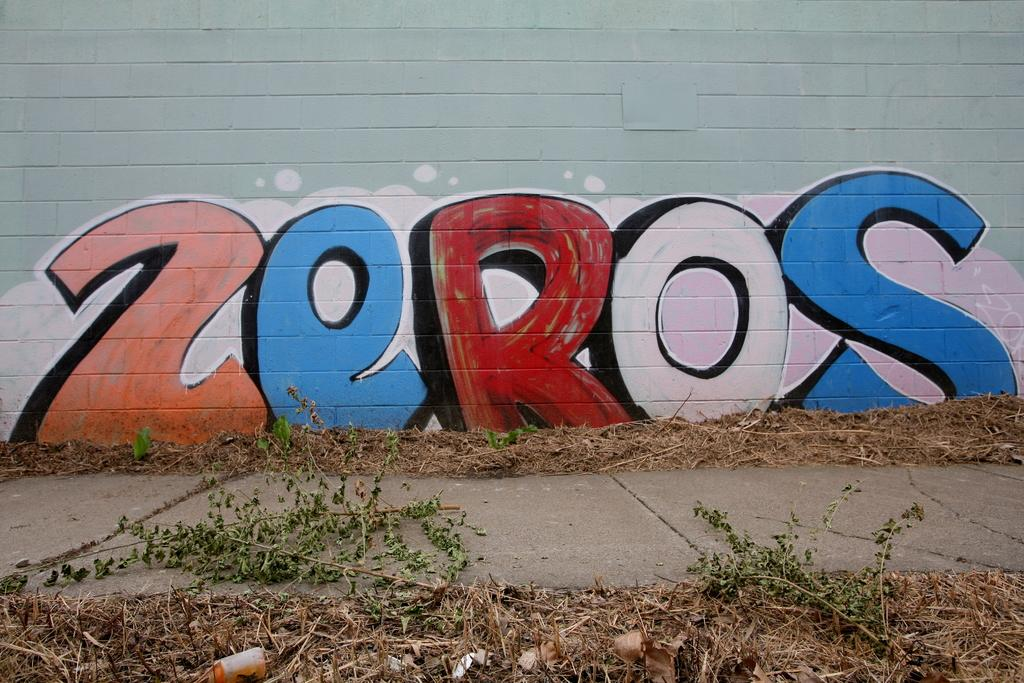What is the main feature in the center of the image? There is a wall in the center of the image. What is written or depicted on the wall? There is text on the wall. What type of vegetation can be seen at the bottom of the image? Dried plants are present at the bottom of the image. What type of ground is visible at the bottom of the image? Grass is visible at the bottom of the image. How many cats can be seen playing with an apparatus in the image? There are no cats or apparatus present in the image. What color is the goldfish swimming in the water in the image? There is no water or goldfish present in the image. 